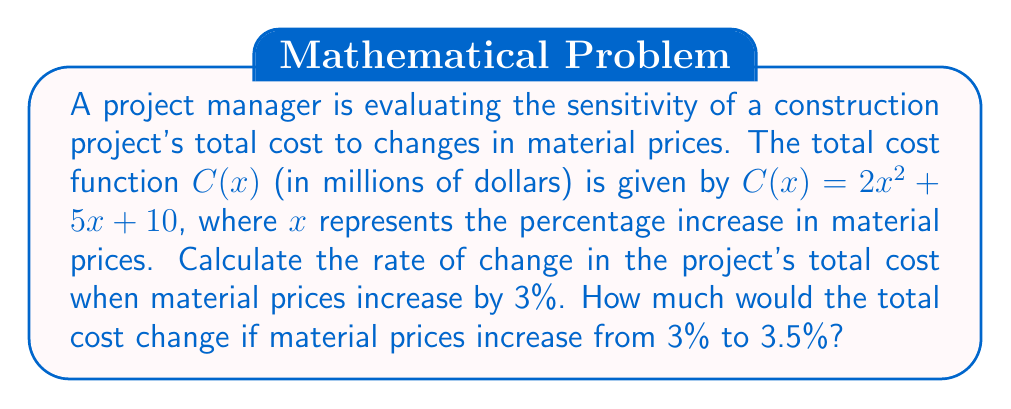Show me your answer to this math problem. 1. To find the rate of change in the project's total cost, we need to calculate the derivative of $C(x)$ and evaluate it at $x = 3$:

   $$C'(x) = 4x + 5$$
   $$C'(3) = 4(3) + 5 = 17$$

   This means that when material prices increase by 3%, the total cost is changing at a rate of 17 million dollars per percentage point.

2. To find the change in total cost when material prices increase from 3% to 3.5%, we can use the Mean Value Theorem or approximate using the derivative:

   $$\Delta C \approx C'(3) \cdot \Delta x$$
   $$\Delta C \approx 17 \cdot 0.5 = 8.5$$

   Therefore, the total cost would increase by approximately 8.5 million dollars.

3. For a more precise answer, we can calculate the actual change:

   $$C(3.5) - C(3) = (2(3.5)^2 + 5(3.5) + 10) - (2(3)^2 + 5(3) + 10)$$
   $$= (24.5 + 17.5 + 10) - (18 + 15 + 10)$$
   $$= 52 - 43 = 9$$

   The actual change in total cost is 9 million dollars.
Answer: Rate of change: $17 million/percentage point. Cost increase: $9 million. 